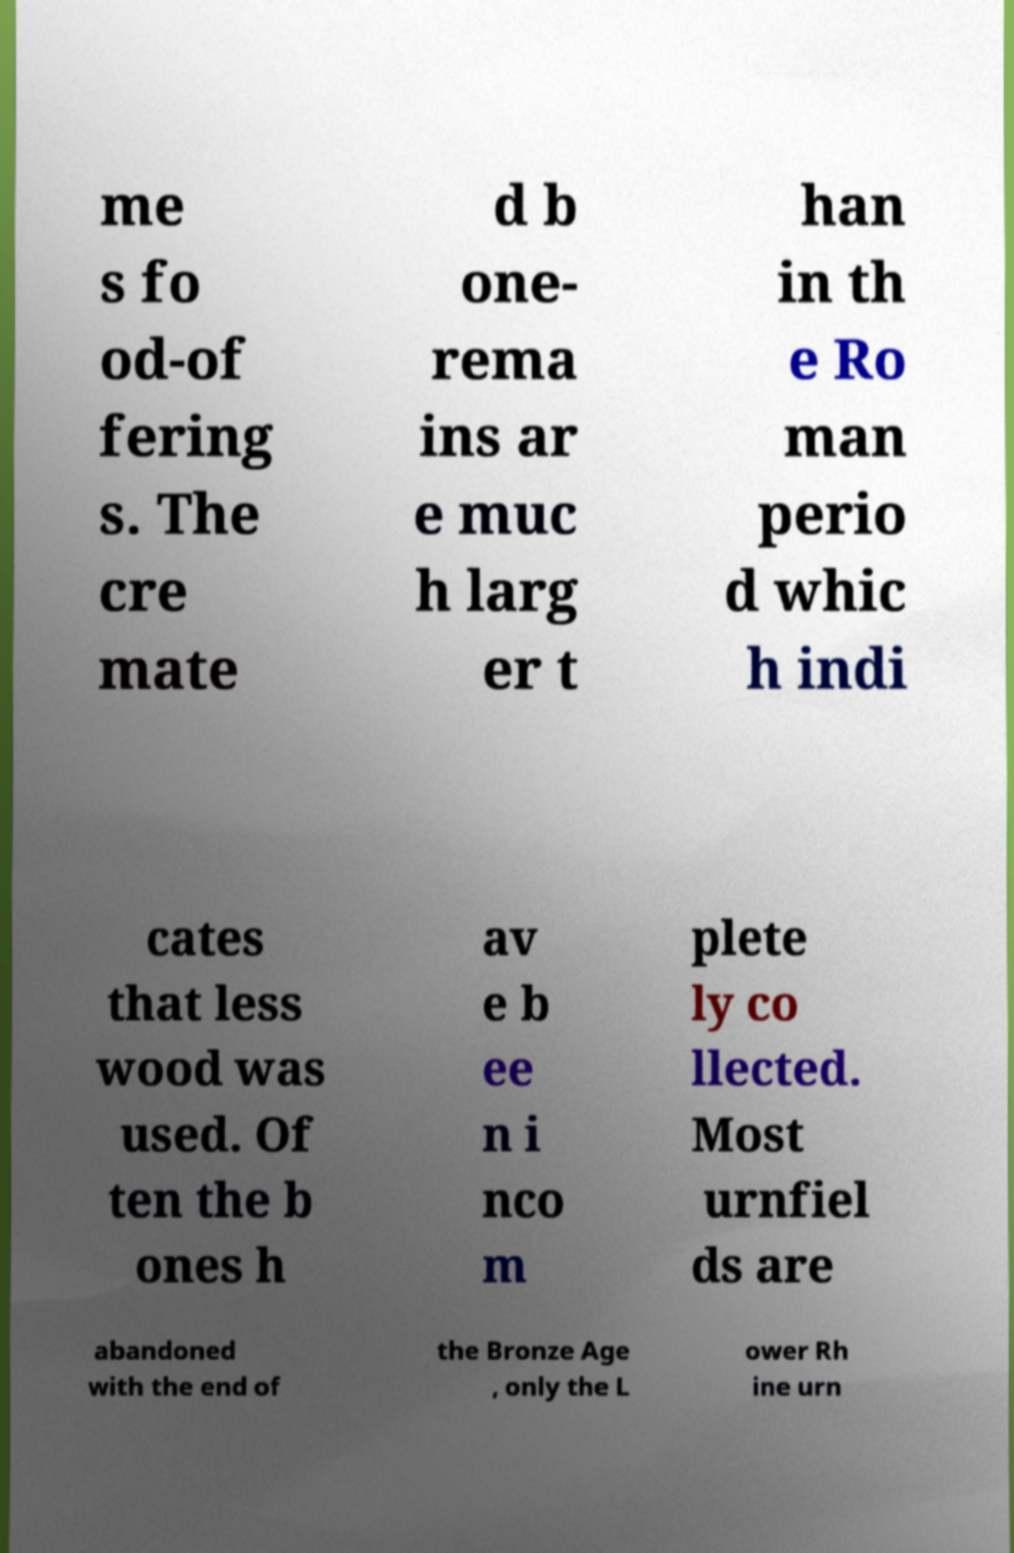Please identify and transcribe the text found in this image. me s fo od-of fering s. The cre mate d b one- rema ins ar e muc h larg er t han in th e Ro man perio d whic h indi cates that less wood was used. Of ten the b ones h av e b ee n i nco m plete ly co llected. Most urnfiel ds are abandoned with the end of the Bronze Age , only the L ower Rh ine urn 